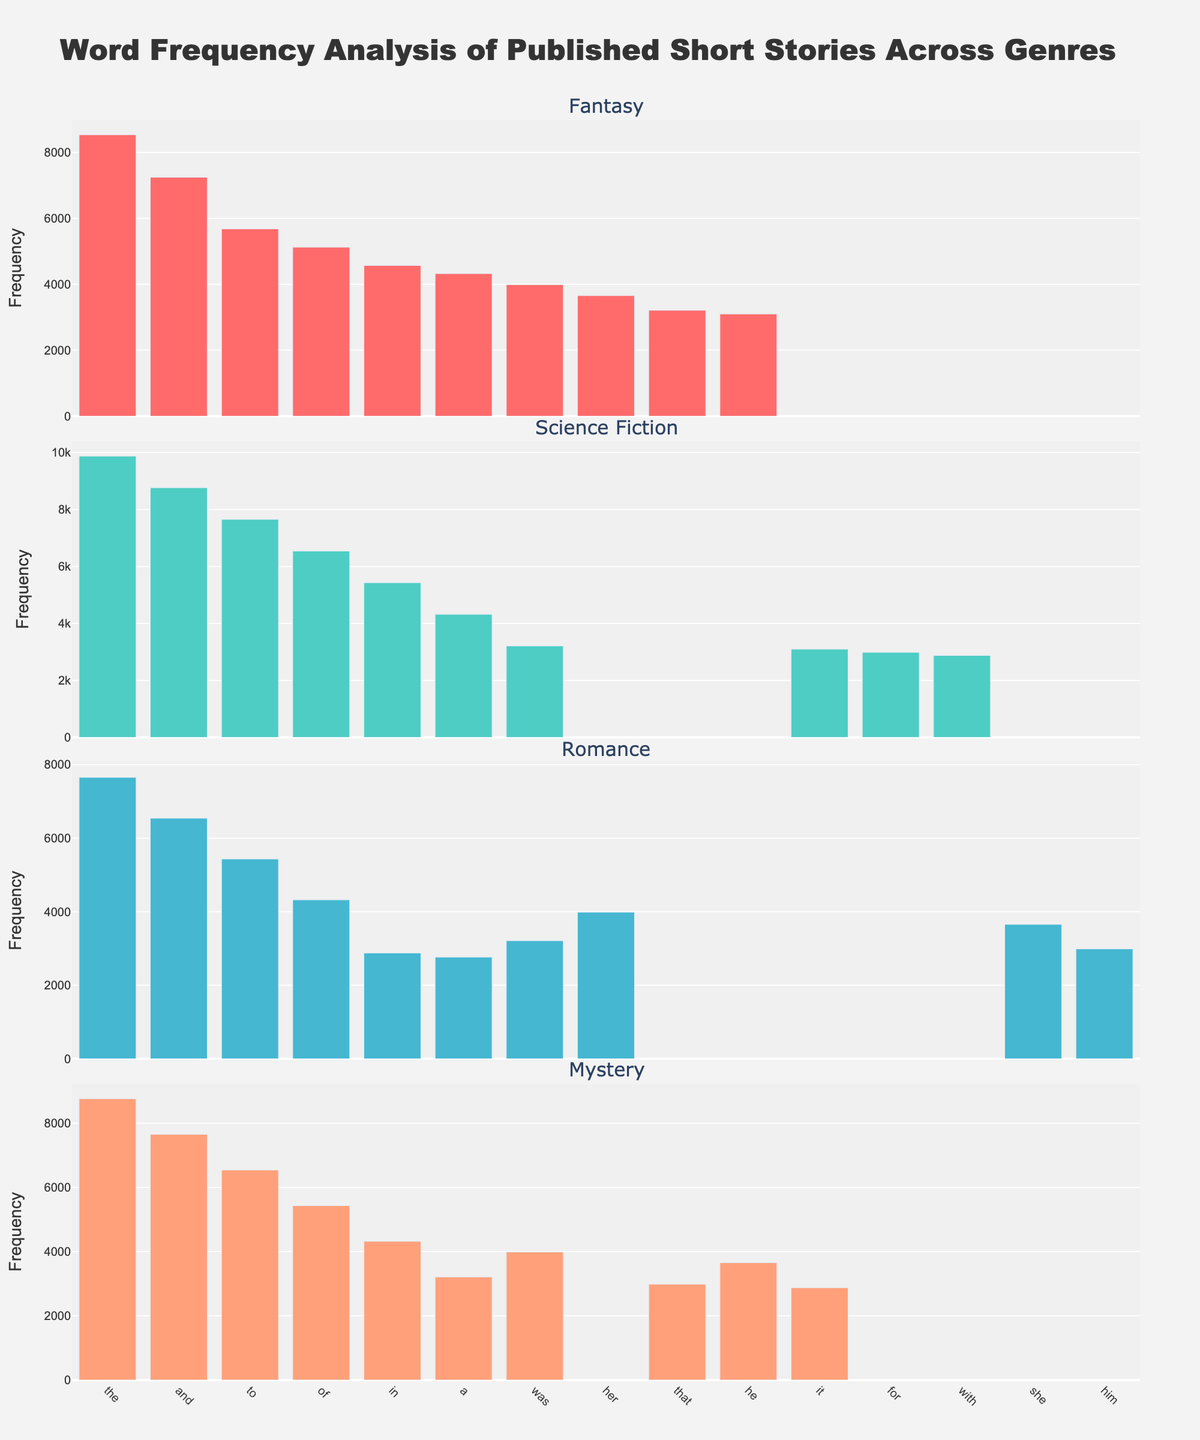What's the highest frequency word in the Fantasy genre? Look for the bar with the highest value in the Fantasy genre subplot. The word "the" has a frequency of 8532, which is the highest in this genre.
Answer: the Which genre has the highest frequency of the word "to"? Check the frequency bar of the word "to" across all genre subplots. Science Fiction shows the highest bar for "to" with a frequency of 7654.
Answer: Science Fiction How many unique words are displayed for each genre? Count the number of bars in each genre subplot. Each subplot has 10 bars representing words.
Answer: 10 What is the frequency difference of the word "was" between Mystery and Romance genres? Check the height of the "was" bar in both the Mystery and Romance subplots. Mystery has 3987, Romance has 3210. The difference is 3987 - 3210.
Answer: 777 What's the average frequency of the word "the" across all genres? Sum the frequencies of the word "the" in all genre subplots and divide by the number of genres: (8532 + 9876 + 7654 + 8765) / 4.
Answer: 8706.75 Which word has the lowest frequency in the Science Fiction genre? Look for the shortest bar in the Science Fiction subplot. The word "with" has the frequency of 2876, which is the lowest.
Answer: with Compare the frequency of the word "her" in Fantasy with that in Romance. Which one is higher? Check the heights of the "her" bars in Fantasy and Romance subplots. In Fantasy, "her" has a frequency of 3654 whereas in Romance it has 3987. Romance is higher.
Answer: Romance What's the range of word frequencies in the Mystery genre? Find the highest and lowest frequency bars in the Mystery subplot, highest is "the" with 8765 and lowest is "it" with 2876. The range is 8765 - 2876.
Answer: 5889 What is the median frequency of words in the Romance genre? Sort the frequencies in the Romance subplot: [2765, 2876, 2987, 3210, 3654, 3987, 4321, 5432, 6543, 7654]. The middle value(s) are 3654 and 3987, average them: (3654 + 3987)/2.
Answer: 3820.5 Which word appears in all four genres with relatively high frequency? Identify a word that has tall bars in all subplots. The word "the" appears in all four genres with high frequencies.
Answer: the 